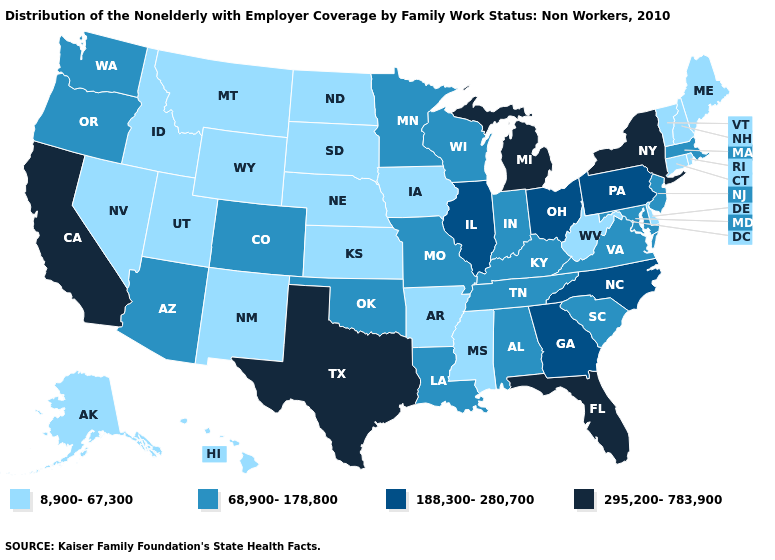Among the states that border Indiana , does Michigan have the highest value?
Write a very short answer. Yes. Name the states that have a value in the range 68,900-178,800?
Write a very short answer. Alabama, Arizona, Colorado, Indiana, Kentucky, Louisiana, Maryland, Massachusetts, Minnesota, Missouri, New Jersey, Oklahoma, Oregon, South Carolina, Tennessee, Virginia, Washington, Wisconsin. Name the states that have a value in the range 295,200-783,900?
Quick response, please. California, Florida, Michigan, New York, Texas. Among the states that border Minnesota , does Wisconsin have the lowest value?
Short answer required. No. Does New Mexico have a higher value than North Carolina?
Keep it brief. No. Name the states that have a value in the range 295,200-783,900?
Quick response, please. California, Florida, Michigan, New York, Texas. What is the value of North Dakota?
Short answer required. 8,900-67,300. Does the map have missing data?
Quick response, please. No. Name the states that have a value in the range 8,900-67,300?
Concise answer only. Alaska, Arkansas, Connecticut, Delaware, Hawaii, Idaho, Iowa, Kansas, Maine, Mississippi, Montana, Nebraska, Nevada, New Hampshire, New Mexico, North Dakota, Rhode Island, South Dakota, Utah, Vermont, West Virginia, Wyoming. Does Tennessee have the lowest value in the USA?
Concise answer only. No. What is the value of North Dakota?
Answer briefly. 8,900-67,300. Which states have the lowest value in the South?
Answer briefly. Arkansas, Delaware, Mississippi, West Virginia. Which states hav the highest value in the MidWest?
Be succinct. Michigan. Which states hav the highest value in the South?
Short answer required. Florida, Texas. What is the highest value in the USA?
Concise answer only. 295,200-783,900. 